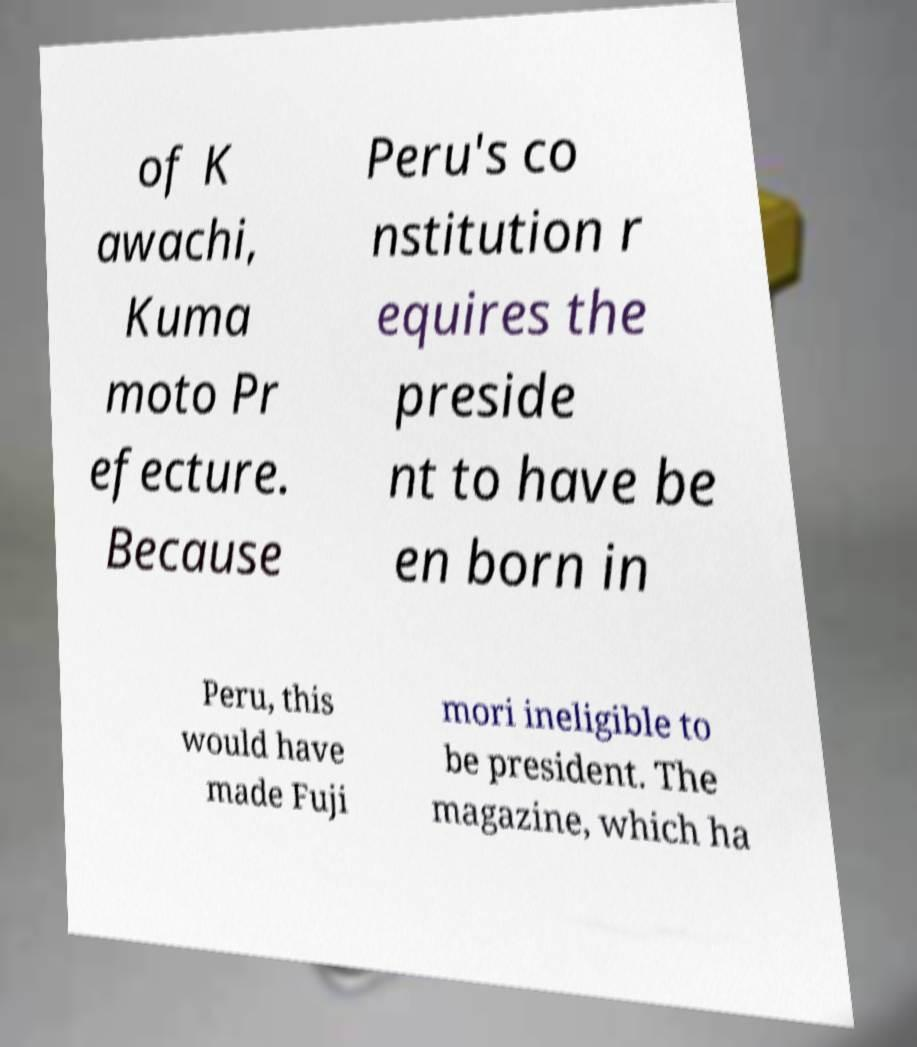I need the written content from this picture converted into text. Can you do that? of K awachi, Kuma moto Pr efecture. Because Peru's co nstitution r equires the preside nt to have be en born in Peru, this would have made Fuji mori ineligible to be president. The magazine, which ha 